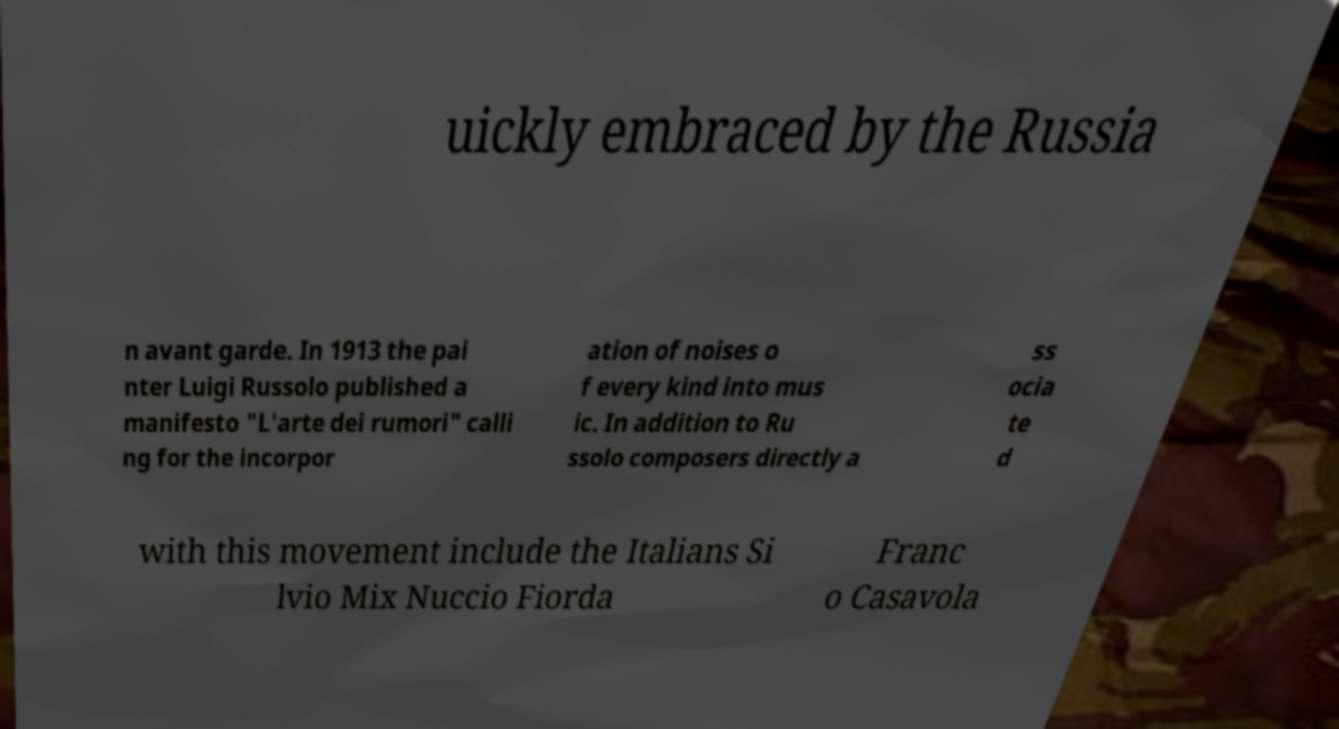There's text embedded in this image that I need extracted. Can you transcribe it verbatim? uickly embraced by the Russia n avant garde. In 1913 the pai nter Luigi Russolo published a manifesto "L'arte dei rumori" calli ng for the incorpor ation of noises o f every kind into mus ic. In addition to Ru ssolo composers directly a ss ocia te d with this movement include the Italians Si lvio Mix Nuccio Fiorda Franc o Casavola 